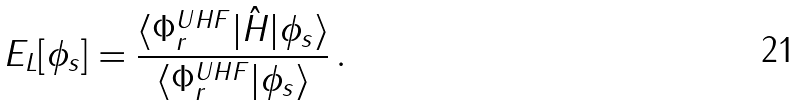<formula> <loc_0><loc_0><loc_500><loc_500>E _ { L } [ \phi _ { s } ] = \frac { \langle \Phi ^ { U H F } _ { r } | \hat { H } | \phi _ { s } \rangle } { \langle \Phi ^ { U H F } _ { r } | \phi _ { s } \rangle } \, .</formula> 